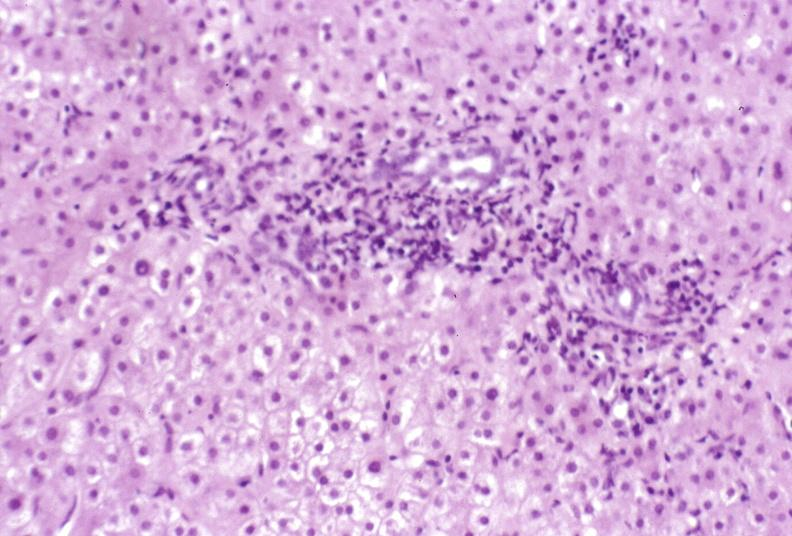does papillary intraductal adenocarcinoma show primary biliary cirrhosis?
Answer the question using a single word or phrase. No 